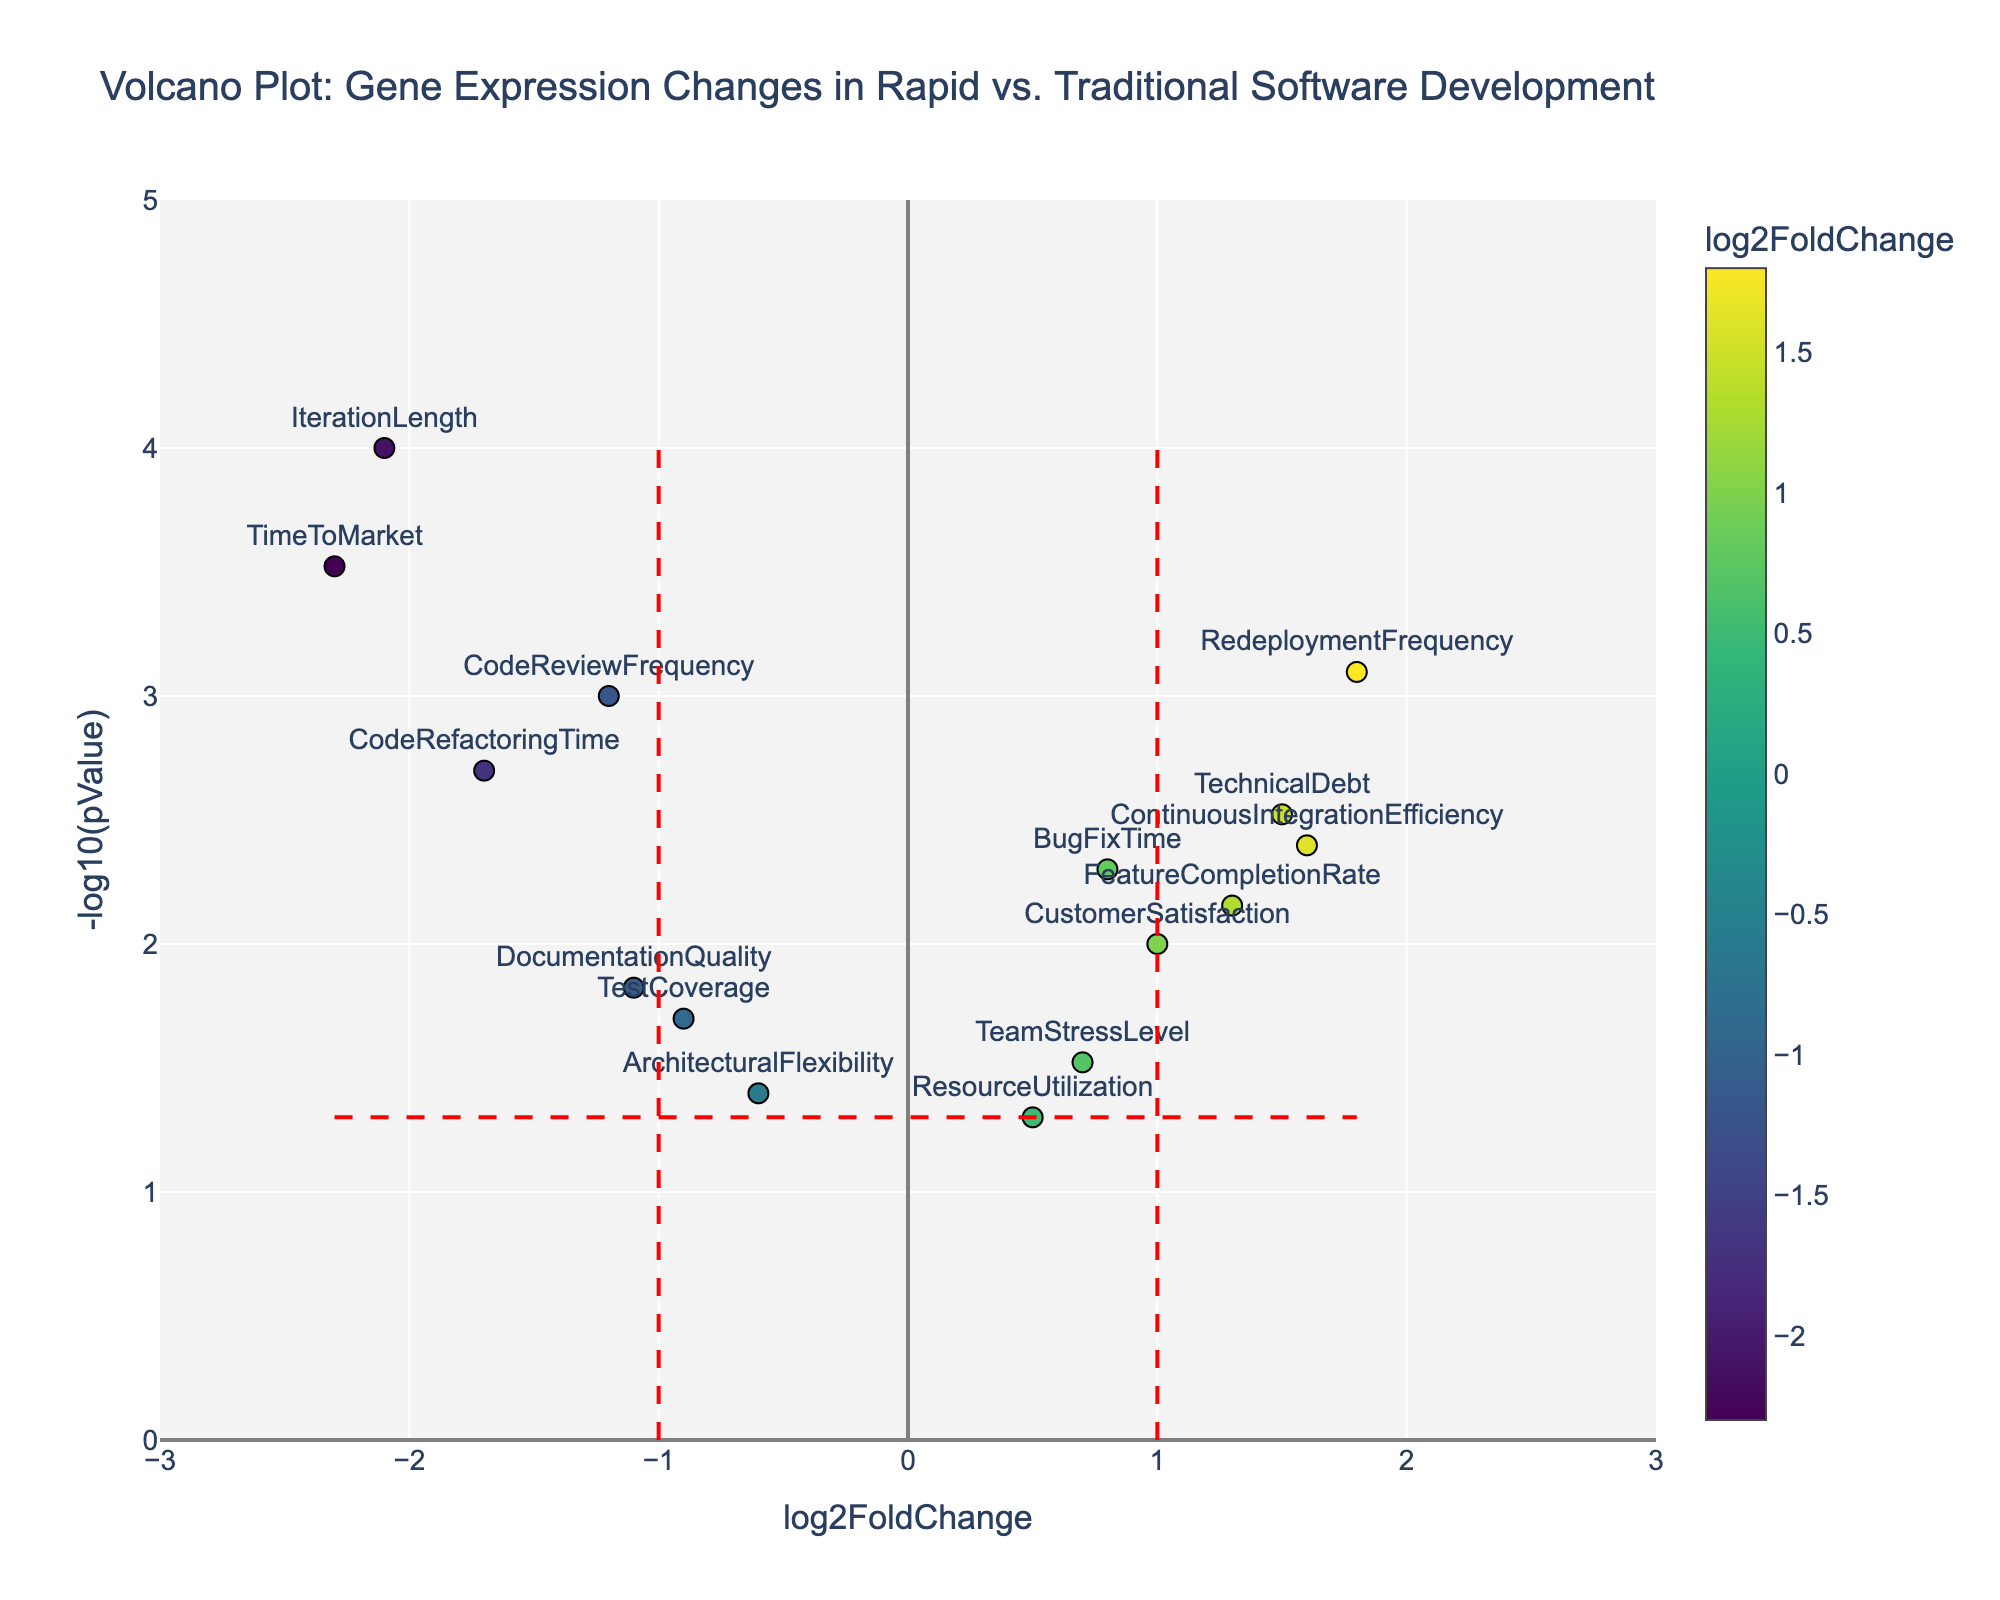How many vertical red dashed lines are there in the figure? There are two vertical red dashed lines positioned on the chart. Each one is at the log2FoldChange values of -1 and 1.
Answer: Two What is the x-axis title of the figure? You can see the title of the x-axis labeled in the figure itself. It is "log2FoldChange".
Answer: log2FoldChange Which gene has the highest -log10(pValue)? Checking the scatter points on the y-axis, "IterationLength" has the highest value at approximately 4.
Answer: IterationLength Which genes fall above the -log10(0.05) horizontal red dashed line and have a positive log2FoldChange? By looking above the horizontal red dashed line and focusing on the positive side of the x-axis, the genes are "TechnicalDebt," "RedeploymentFrequency," "FeatureCompletionRate," "CustomerSatisfaction," and "ContinuousIntegrationEfficiency."
Answer: TechnicalDebt, RedeploymentFrequency, FeatureCompletionRate, CustomerSatisfaction, ContinuousIntegrationEfficiency What is the title of the figure? The title is located at the top of the figure and is "Volcano Plot: Gene Expression Changes in Rapid vs. Traditional Software Development."
Answer: Volcano Plot: Gene Expression Changes in Rapid vs. Traditional Software Development Is "CodeRefactoringTime" upregulated or downregulated? Find "CodeRefactoringTime" on the plot and see its position on the x-axis. It is on the negative side of the x-axis, indicating downregulation.
Answer: Downregulated How many genes have a significant p-value less than 0.05 but are not upregulated? Focus on the points above the horizontal red dashed line (indicating p-value less than 0.05) on the negative side of the x-axis (indicating not upregulated). The genes are "CodeReviewFrequency," "IterationLength," "CodeRefactoringTime," "DocumentationQuality," and "TimeToMarket."
Answer: 5 genes Which gene has the lowest log2FoldChange? Check the x-axis values, and see that "TimeToMarket" has the most negative value at approximately -2.3.
Answer: TimeToMarket How does the "CustomerSatisfaction" gene compare to "TeamStressLevel" in terms of log2FoldChange? Compare "CustomerSatisfaction" and "TeamStressLevel" on the x-axis. "CustomerSatisfaction" (log2FoldChange = 1.0) is higher than "TeamStressLevel" (log2FoldChange = 0.7).
Answer: CustomerSatisfaction has a higher log2FoldChange than TeamStressLevel Which gene is closest to the vertical line at log2FoldChange = -1? Find the points on the plot close to the vertical red dashed line at log2FoldChange = -1. "CodeReviewFrequency" is closest with a log2FoldChange of -1.2.
Answer: CodeReviewFrequency 